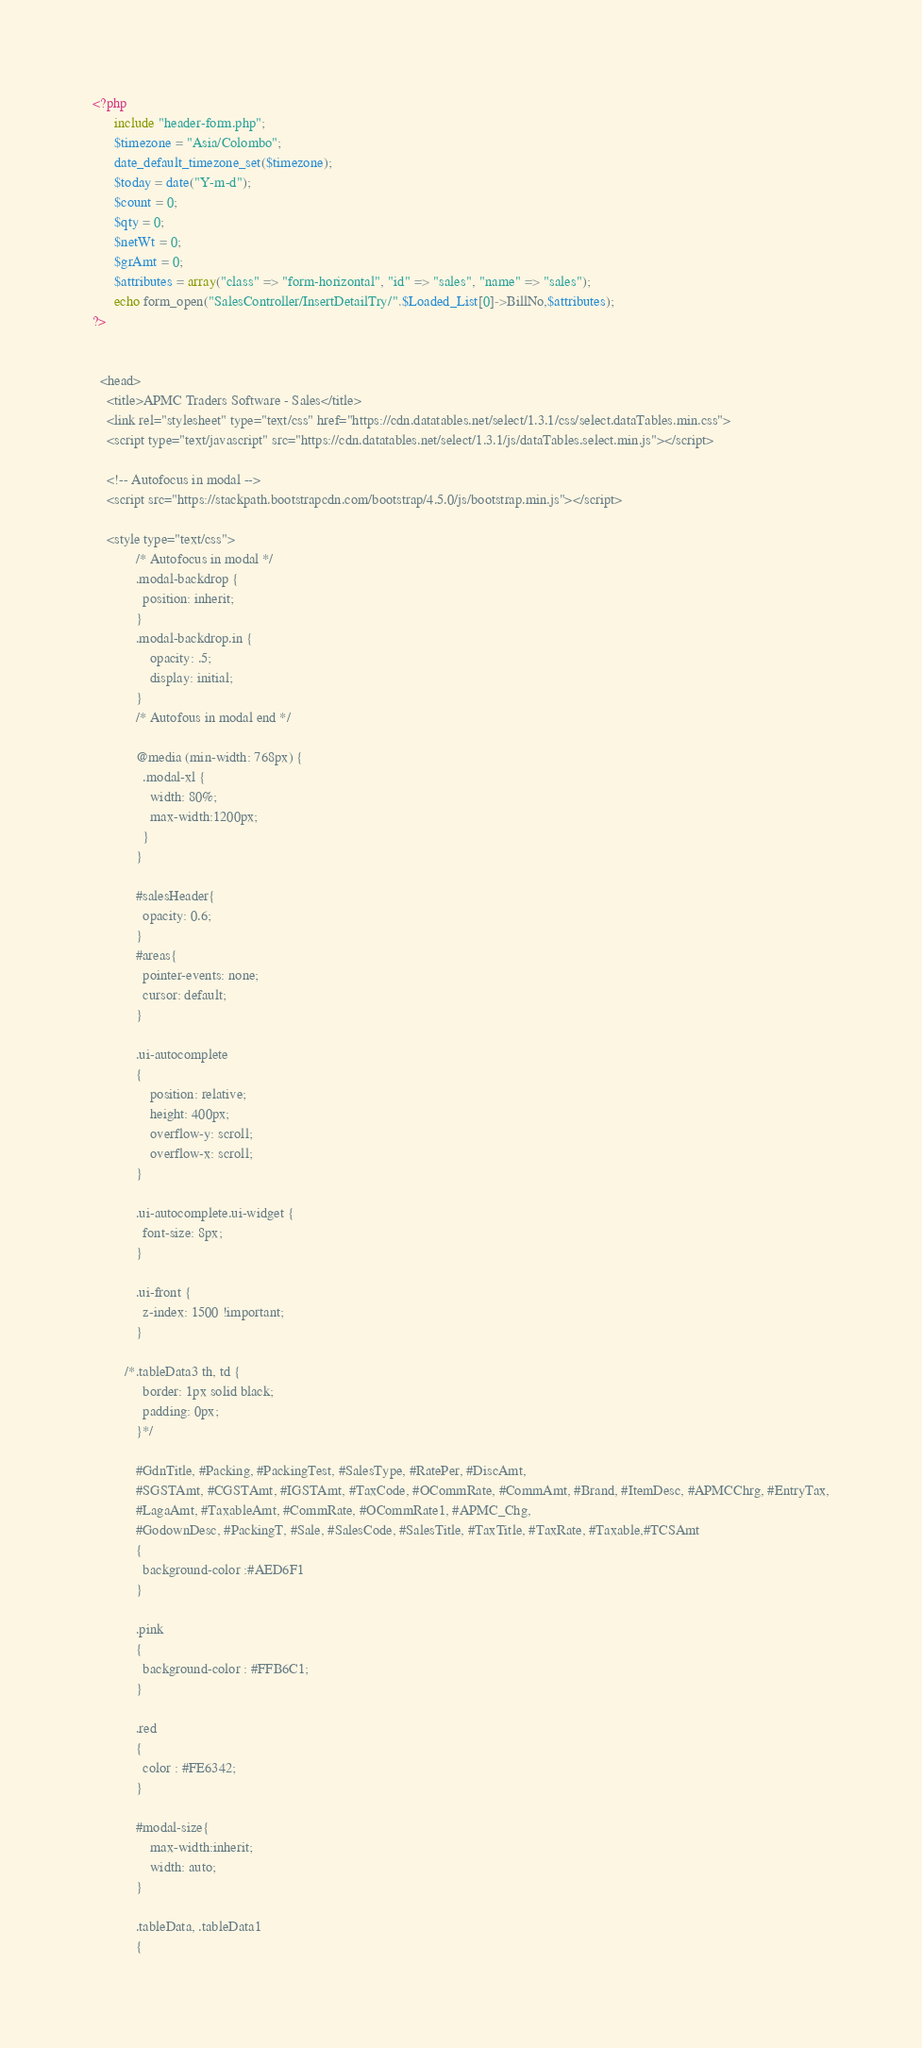Convert code to text. <code><loc_0><loc_0><loc_500><loc_500><_PHP_><?php
      include "header-form.php";
      $timezone = "Asia/Colombo";
      date_default_timezone_set($timezone);
      $today = date("Y-m-d");
      $count = 0;
      $qty = 0;
      $netWt = 0;
      $grAmt = 0;
      $attributes = array("class" => "form-horizontal", "id" => "sales", "name" => "sales");
      echo form_open("SalesController/InsertDetailTry/".$Loaded_List[0]->BillNo,$attributes);
?>


  <head>
    <title>APMC Traders Software - Sales</title>
    <link rel="stylesheet" type="text/css" href="https://cdn.datatables.net/select/1.3.1/css/select.dataTables.min.css">
    <script type="text/javascript" src="https://cdn.datatables.net/select/1.3.1/js/dataTables.select.min.js"></script>  
    
    <!-- Autofocus in modal -->
    <script src="https://stackpath.bootstrapcdn.com/bootstrap/4.5.0/js/bootstrap.min.js"></script>

    <style type="text/css">
            /* Autofocus in modal */
            .modal-backdrop {
              position: inherit;
            }
            .modal-backdrop.in {
                opacity: .5;
                display: initial;
            }
            /* Autofous in modal end */

            @media (min-width: 768px) {
              .modal-xl {
                width: 80%;
                max-width:1200px;
              }
            }

            #salesHeader{
              opacity: 0.6;
            }
            #areas{
              pointer-events: none;
              cursor: default;
            }

            .ui-autocomplete 
            { 
                position: relative;
                height: 400px; 
                overflow-y: scroll; 
                overflow-x: scroll;
            }

            .ui-autocomplete.ui-widget {
              font-size: 8px;
            }

            .ui-front {
              z-index: 1500 !important;
            }
            
         /*.tableData3 th, td {
              border: 1px solid black;
              padding: 0px;
            }*/

            #GdnTitle, #Packing, #PackingTest, #SalesType, #RatePer, #DiscAmt, 
            #SGSTAmt, #CGSTAmt, #IGSTAmt, #TaxCode, #OCommRate, #CommAmt, #Brand, #ItemDesc, #APMCChrg, #EntryTax,
            #LagaAmt, #TaxableAmt, #CommRate, #OCommRate1, #APMC_Chg, 
            #GodownDesc, #PackingT, #Sale, #SalesCode, #SalesTitle, #TaxTitle, #TaxRate, #Taxable,#TCSAmt
            {
              background-color :#AED6F1
            }

            .pink
            {
              background-color : #FFB6C1;
            }

            .red
            {
              color : #FE6342;
            }

            #modal-size{
                max-width:inherit;
                width: auto;
            }

            .tableData, .tableData1
            {</code> 